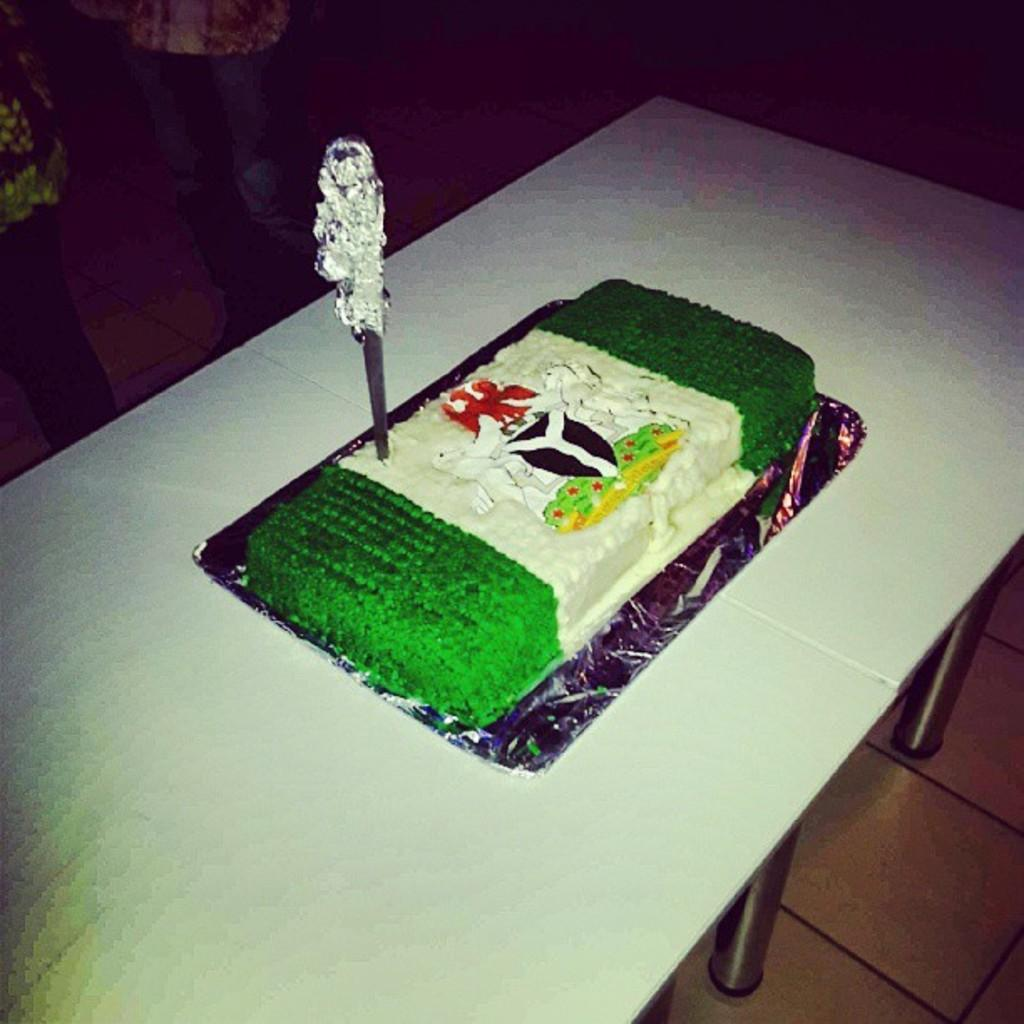What is the main object on the table in the image? There is a cake on a table in the image. How is the cake being interacted with? A knife is poked into the cake. Can you describe the condition of the cake? The cake has a knife poked into it, which suggests it might have been cut or prepared for cutting. What type of disease can be seen affecting the cake in the image? There is no disease affecting the cake in the image; it appears to be a normal cake with a knife poked into it. What type of pickle is placed on top of the cake in the image? There is no pickle present on the cake in the image. 